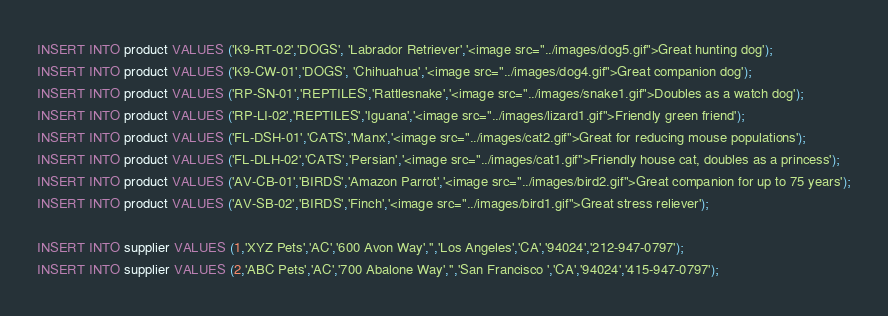<code> <loc_0><loc_0><loc_500><loc_500><_SQL_>INSERT INTO product VALUES ('K9-RT-02','DOGS', 'Labrador Retriever','<image src="../images/dog5.gif">Great hunting dog');
INSERT INTO product VALUES ('K9-CW-01','DOGS', 'Chihuahua','<image src="../images/dog4.gif">Great companion dog');
INSERT INTO product VALUES ('RP-SN-01','REPTILES','Rattlesnake','<image src="../images/snake1.gif">Doubles as a watch dog');
INSERT INTO product VALUES ('RP-LI-02','REPTILES','Iguana','<image src="../images/lizard1.gif">Friendly green friend');
INSERT INTO product VALUES ('FL-DSH-01','CATS','Manx','<image src="../images/cat2.gif">Great for reducing mouse populations');
INSERT INTO product VALUES ('FL-DLH-02','CATS','Persian','<image src="../images/cat1.gif">Friendly house cat, doubles as a princess');
INSERT INTO product VALUES ('AV-CB-01','BIRDS','Amazon Parrot','<image src="../images/bird2.gif">Great companion for up to 75 years');
INSERT INTO product VALUES ('AV-SB-02','BIRDS','Finch','<image src="../images/bird1.gif">Great stress reliever');

INSERT INTO supplier VALUES (1,'XYZ Pets','AC','600 Avon Way','','Los Angeles','CA','94024','212-947-0797');
INSERT INTO supplier VALUES (2,'ABC Pets','AC','700 Abalone Way','','San Francisco ','CA','94024','415-947-0797');
</code> 